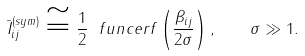<formula> <loc_0><loc_0><loc_500><loc_500>\bar { I } _ { i j } ^ { ( s y m ) } \cong \frac { 1 } { 2 } \ f u n c { e r f } \left ( \frac { \beta _ { i j } } { 2 \sigma } \right ) , \quad \sigma \gg 1 .</formula> 